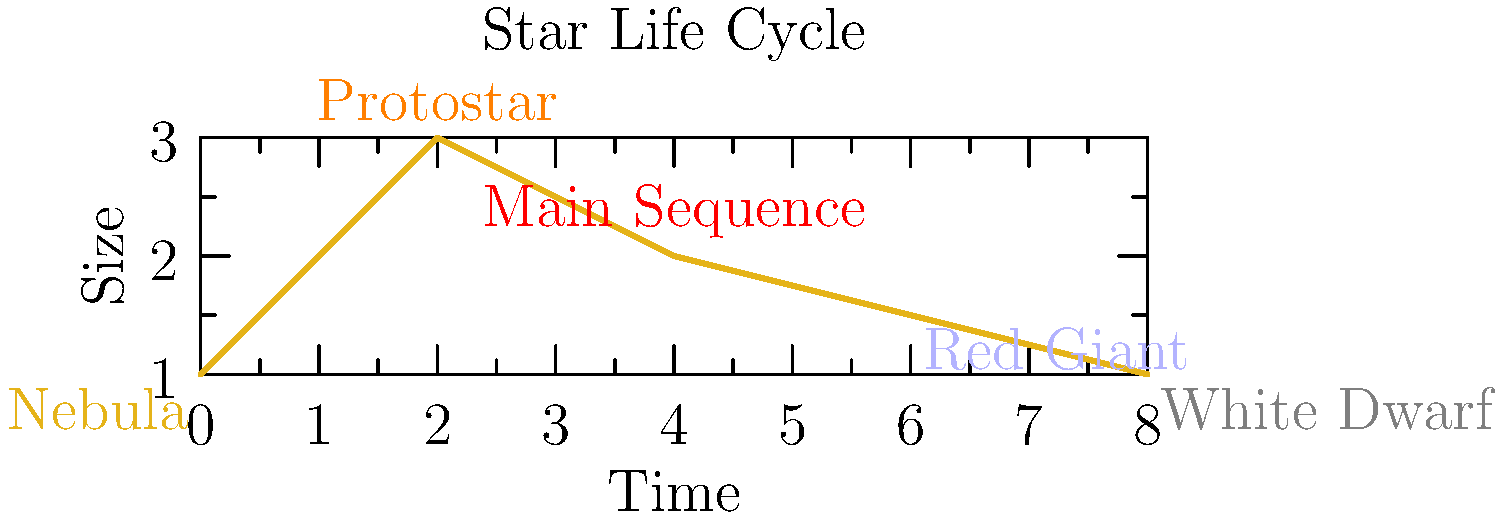In the context of food preservation, understanding natural processes can provide valuable insights. Consider the life cycle of a star as shown in the graph. Which stage represents the longest period in a star's life, similar to how certain preservation methods aim to extend the shelf life of food products? To answer this question, let's analyze the star's life cycle stages:

1. Nebula: The starting point, where gas and dust begin to collapse.
2. Protostar: A short phase where the collapsing material begins to heat up.
3. Main Sequence: The longest and most stable phase of a star's life.
4. Red Giant: An expansion phase near the end of the star's life.
5. White Dwarf: The final stage for most stars.

The Main Sequence stage is represented by the plateau in the middle of the graph. This stage is characterized by:

a) Stability: The star maintains a relatively constant size and temperature.
b) Duration: It typically lasts for billions of years, much longer than other stages.
c) Energy production: Consistent fusion of hydrogen into helium occurs.

In the context of food preservation, this stage is analogous to the desired state of preserved food:
- Stability in quality and safety
- Extended duration of usability
- Consistent characteristics over time

Therefore, the Main Sequence stage represents the longest period in a star's life, similar to how effective preservation methods aim to extend the stable, usable period of food products.
Answer: Main Sequence 